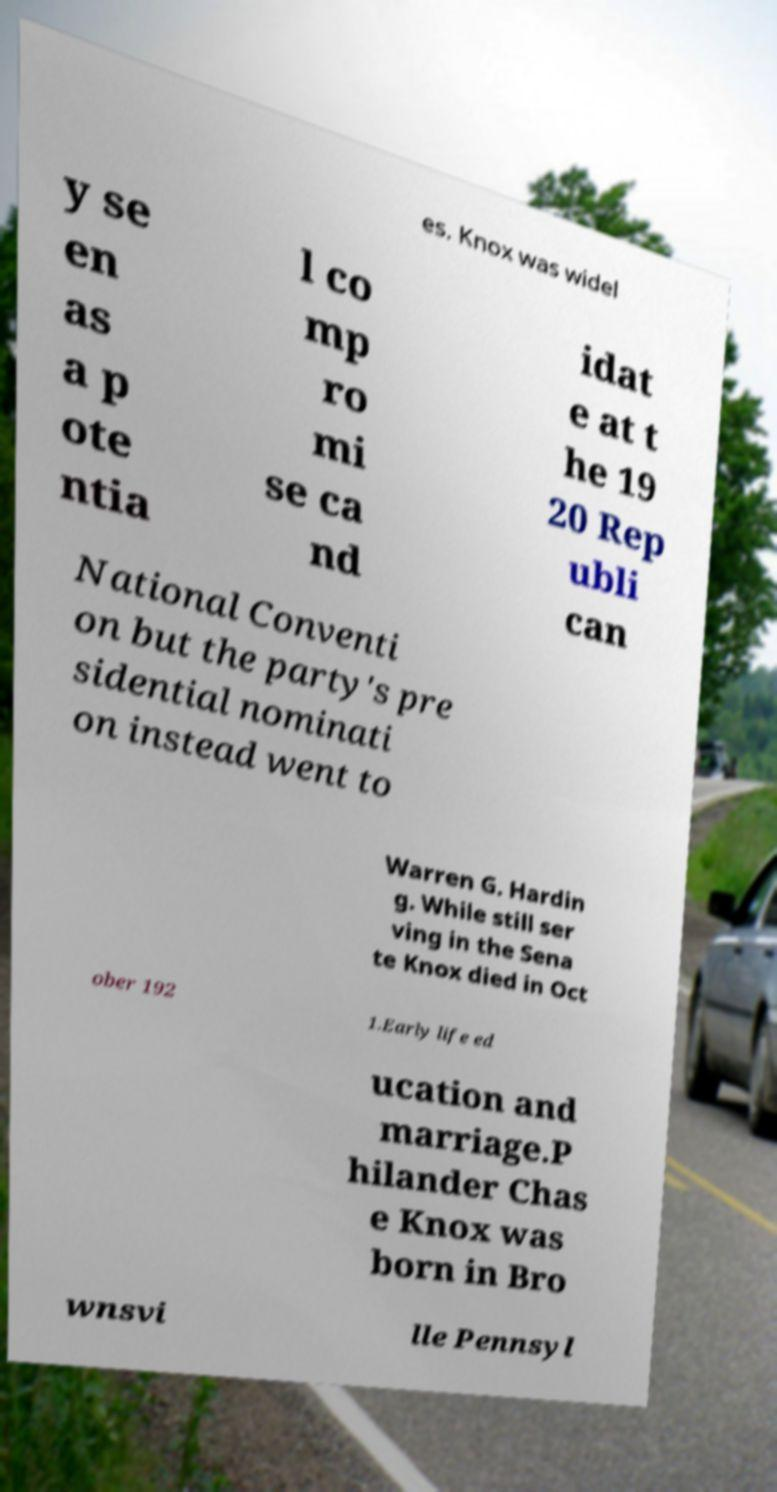For documentation purposes, I need the text within this image transcribed. Could you provide that? es. Knox was widel y se en as a p ote ntia l co mp ro mi se ca nd idat e at t he 19 20 Rep ubli can National Conventi on but the party's pre sidential nominati on instead went to Warren G. Hardin g. While still ser ving in the Sena te Knox died in Oct ober 192 1.Early life ed ucation and marriage.P hilander Chas e Knox was born in Bro wnsvi lle Pennsyl 